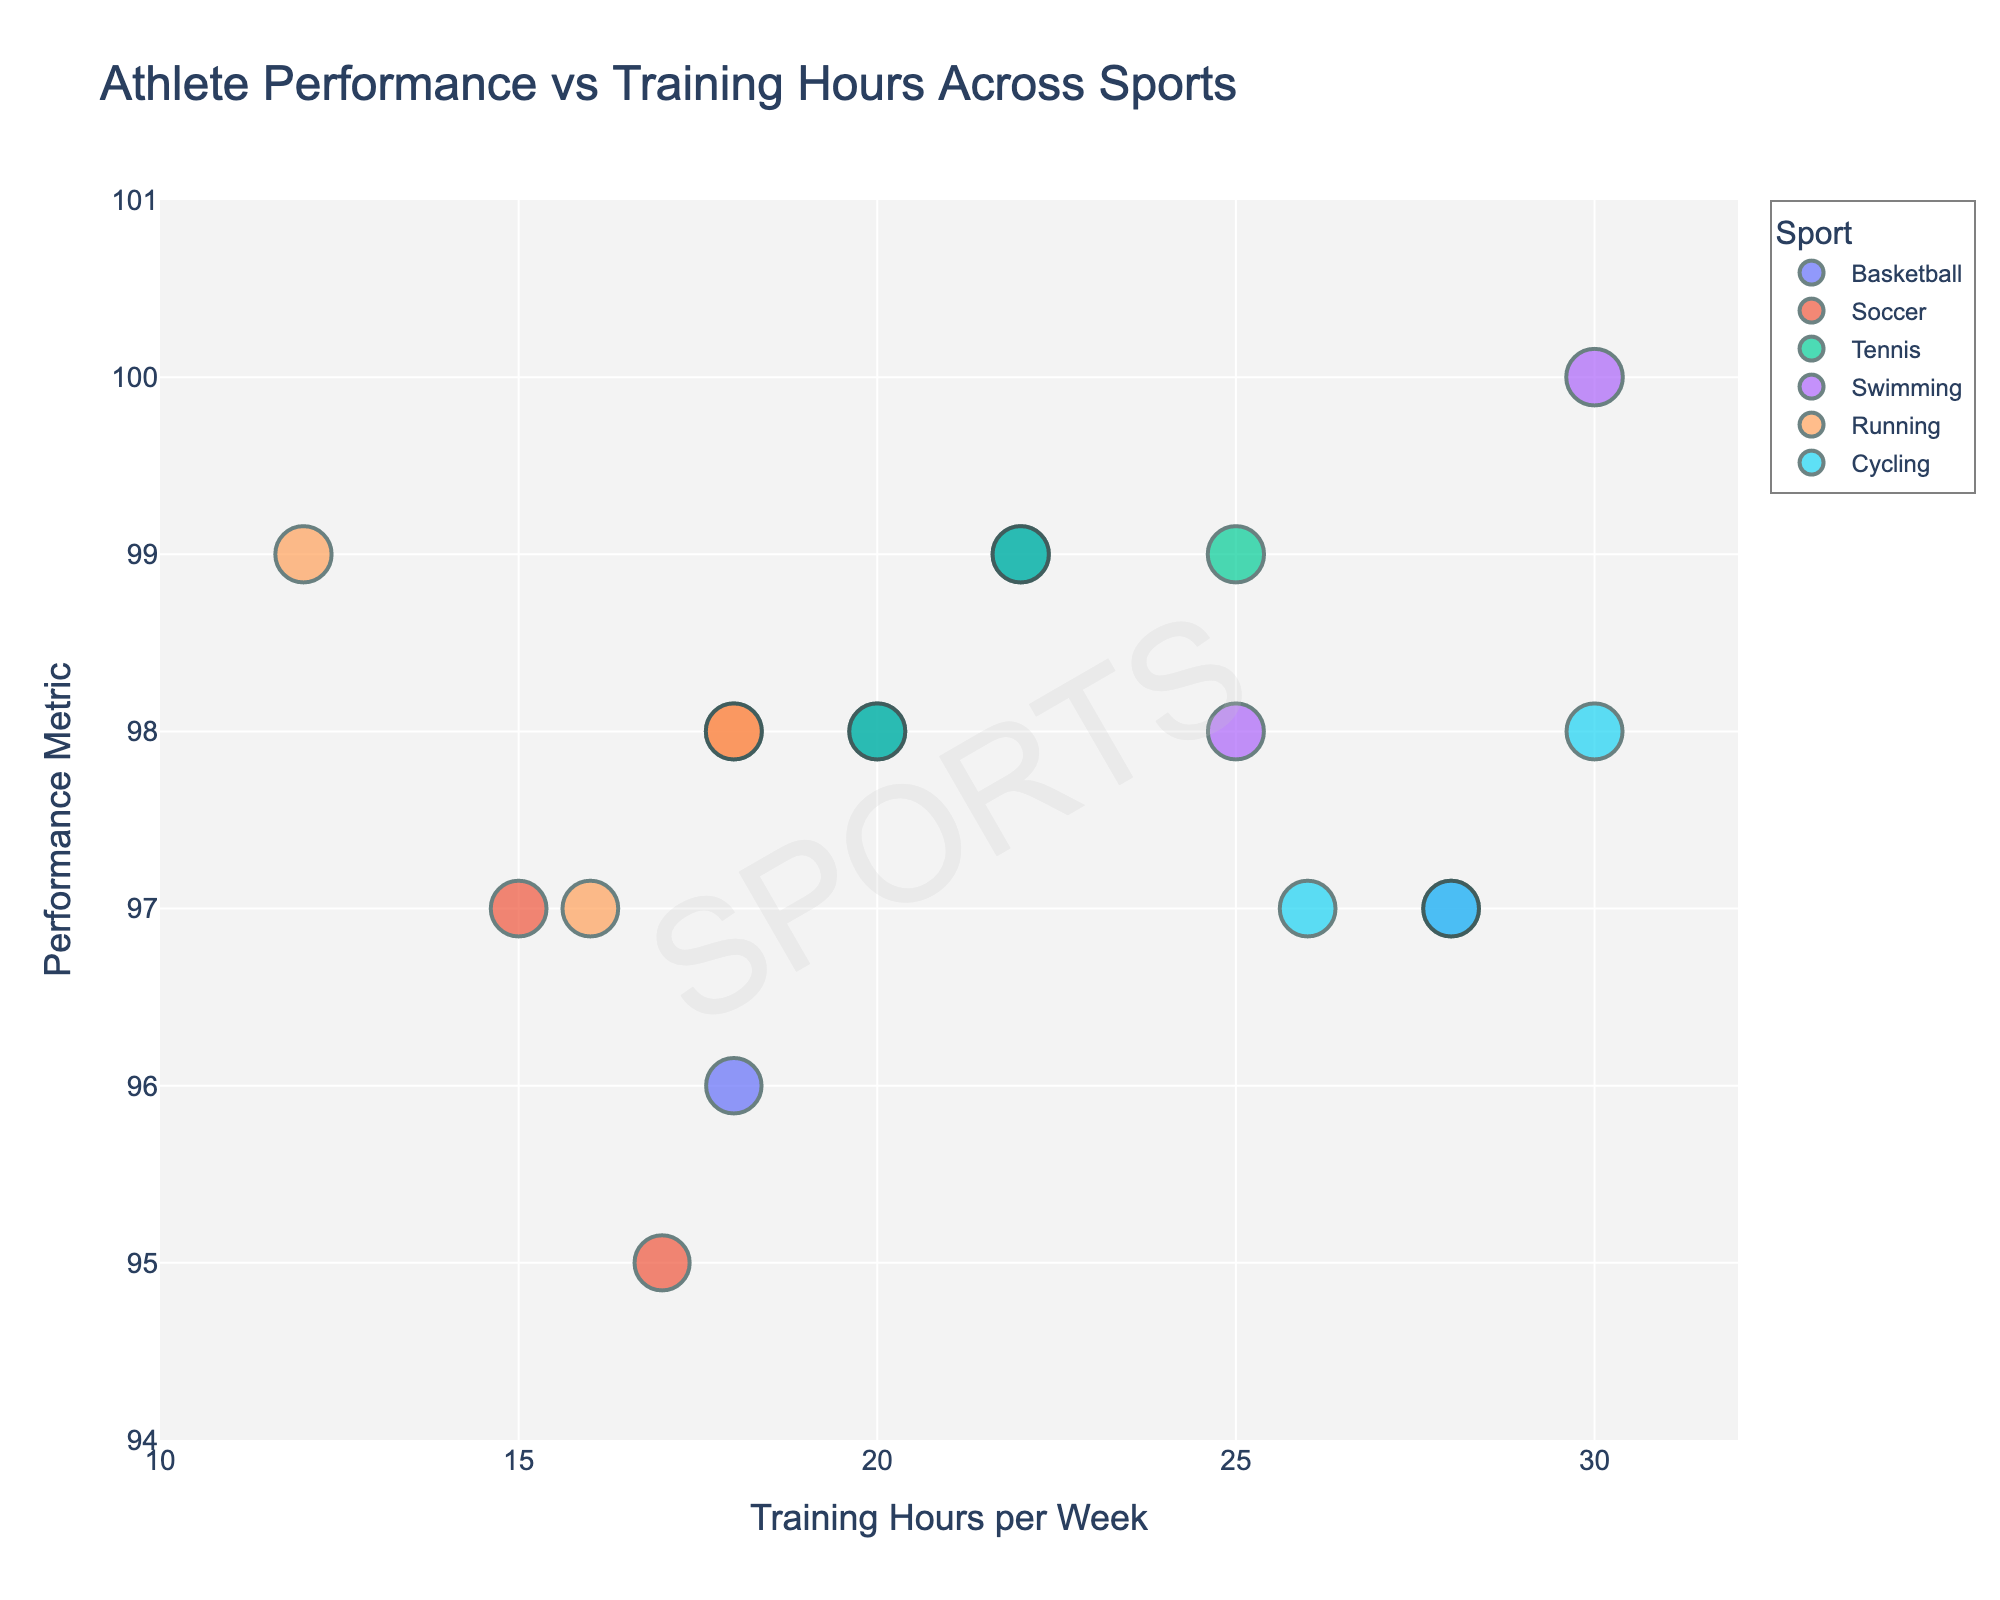What is the title of the plot? The title is displayed at the top of the plot, indicating what the plot is about. It provides a quick understanding of the plot's purpose.
Answer: Athlete Performance vs Training Hours Across Sports How many athletes are represented in the Swimming category? Identify all data points in the Swimming category by their color and count them.
Answer: 3 Which sport has athletes with the highest training hours per week in the plot? Locate the sports categories on the x-axis (Training Hours per Week) and identify the one with the highest values.
Answer: Swimming What is the performance metric of the athlete who trains the least per week? Find the athlete with the smallest training hours on the x-axis and read the corresponding performance metric on the y-axis.
Answer: 99 Which two sports have athletes training around 20 hours per week with similar performance metrics? Compare the positions around 20 hours on the x-axis for each sport and identify the sports with overlapping or close performance metrics on the y-axis.
Answer: Basketball and Tennis What is the average performance metric for athletes in the Running category? Calculate the mean of the performance metrics for athletes in Running by adding them and dividing by the number of athletes. (99 + 97 + 98) / 3 = 98
Answer: 98 Are there any sports where athletes train more than 25 hours per week but have performance metrics below 98? Check the data points above 25 hours on the x-axis and see if any corresponding y-values (performance metrics) are below 98.
Answer: Yes (Cycling, Swimming) Which athlete has the maximum performance metric, and how many hours do they train per week? Identify the highest point on the y-axis (maximum performance metric) and read the corresponding x-axis (training hours) and name (using hover information).
Answer: Michael Phelps, 30 Do Tennis players generally train more or less than Soccer players? Compare the positions of Tennis and Soccer data points on the x-axis to see which group leans towards higher or lower training hours.
Answer: More Which sport shows the most significant variation in training hours among its athletes? Observe the spread of data points along the x-axis for each sport to determine the one with the widest range of training hours.
Answer: Cycling 